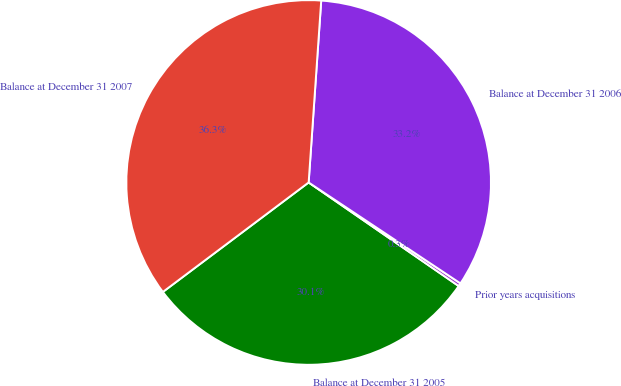Convert chart. <chart><loc_0><loc_0><loc_500><loc_500><pie_chart><fcel>Balance at December 31 2005<fcel>Prior years acquisitions<fcel>Balance at December 31 2006<fcel>Balance at December 31 2007<nl><fcel>30.13%<fcel>0.28%<fcel>33.24%<fcel>36.35%<nl></chart> 